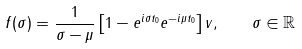<formula> <loc_0><loc_0><loc_500><loc_500>f ( \sigma ) = \frac { 1 } { \sigma - \mu } \left [ 1 - e ^ { i \sigma t _ { 0 } } e ^ { - i \mu t _ { 0 } } \right ] v , \quad \sigma \in \mathbb { R }</formula> 